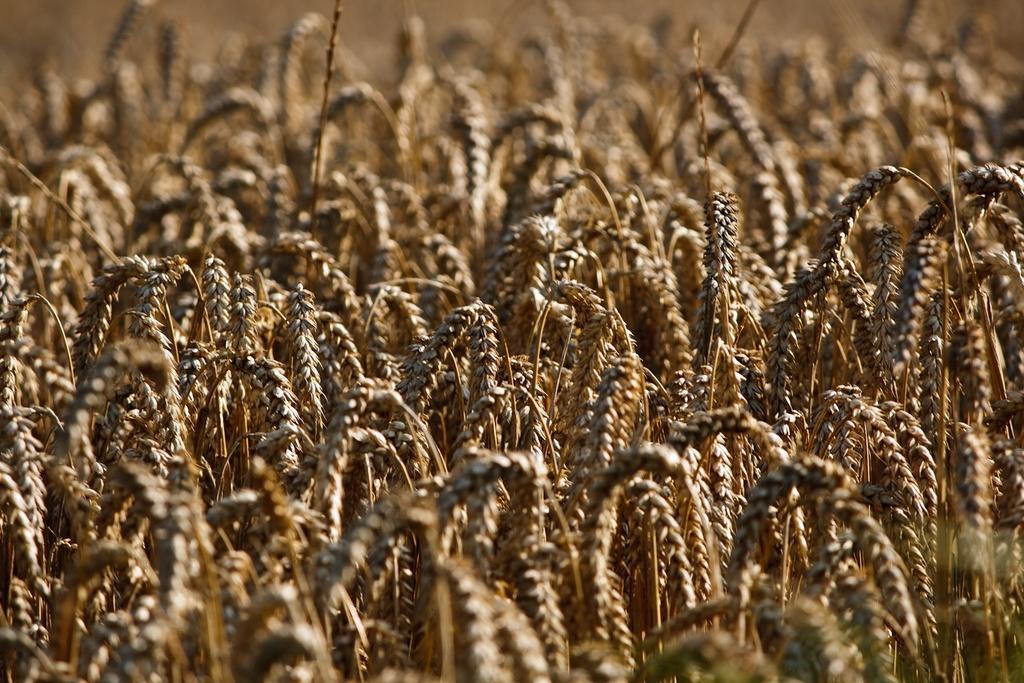Can you describe this image briefly? This image is taken in a wheat field. 